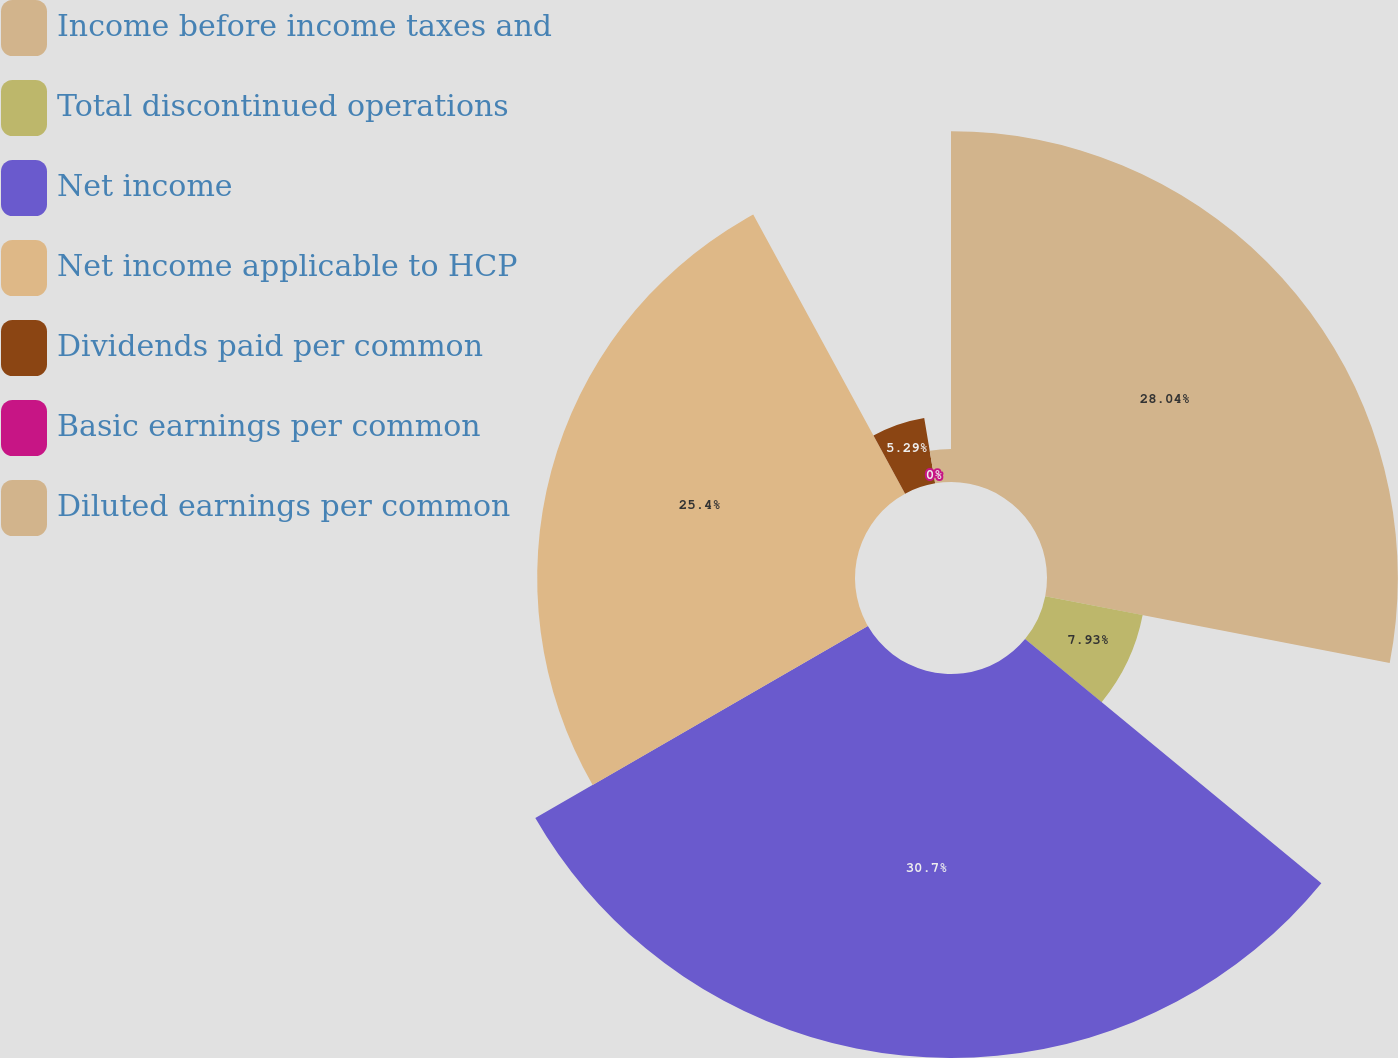Convert chart. <chart><loc_0><loc_0><loc_500><loc_500><pie_chart><fcel>Income before income taxes and<fcel>Total discontinued operations<fcel>Net income<fcel>Net income applicable to HCP<fcel>Dividends paid per common<fcel>Basic earnings per common<fcel>Diluted earnings per common<nl><fcel>28.04%<fcel>7.93%<fcel>30.69%<fcel>25.4%<fcel>5.29%<fcel>0.0%<fcel>2.64%<nl></chart> 